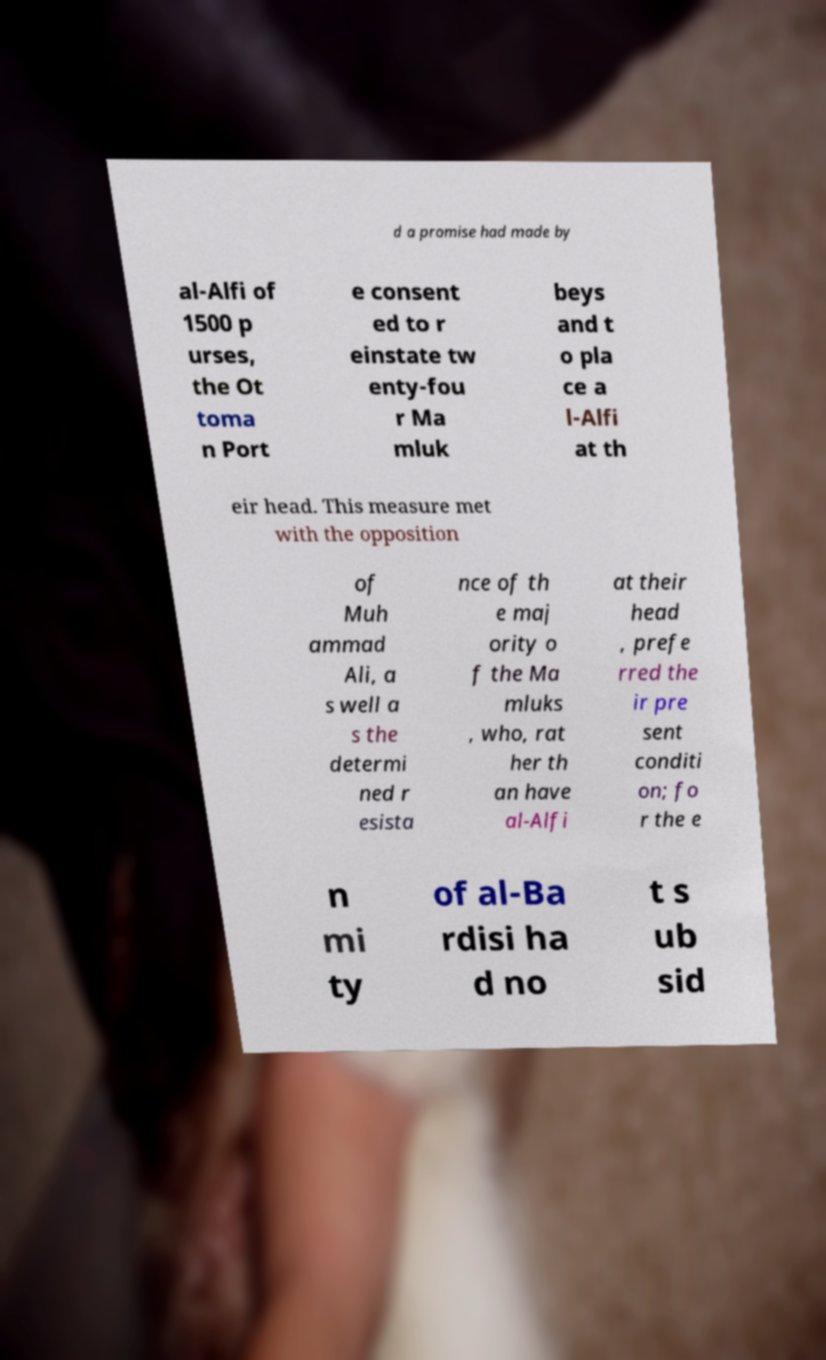For documentation purposes, I need the text within this image transcribed. Could you provide that? d a promise had made by al-Alfi of 1500 p urses, the Ot toma n Port e consent ed to r einstate tw enty-fou r Ma mluk beys and t o pla ce a l-Alfi at th eir head. This measure met with the opposition of Muh ammad Ali, a s well a s the determi ned r esista nce of th e maj ority o f the Ma mluks , who, rat her th an have al-Alfi at their head , prefe rred the ir pre sent conditi on; fo r the e n mi ty of al-Ba rdisi ha d no t s ub sid 